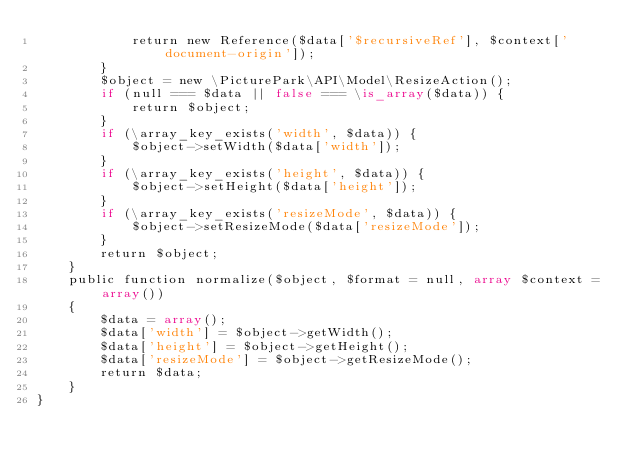<code> <loc_0><loc_0><loc_500><loc_500><_PHP_>            return new Reference($data['$recursiveRef'], $context['document-origin']);
        }
        $object = new \PicturePark\API\Model\ResizeAction();
        if (null === $data || false === \is_array($data)) {
            return $object;
        }
        if (\array_key_exists('width', $data)) {
            $object->setWidth($data['width']);
        }
        if (\array_key_exists('height', $data)) {
            $object->setHeight($data['height']);
        }
        if (\array_key_exists('resizeMode', $data)) {
            $object->setResizeMode($data['resizeMode']);
        }
        return $object;
    }
    public function normalize($object, $format = null, array $context = array())
    {
        $data = array();
        $data['width'] = $object->getWidth();
        $data['height'] = $object->getHeight();
        $data['resizeMode'] = $object->getResizeMode();
        return $data;
    }
}</code> 